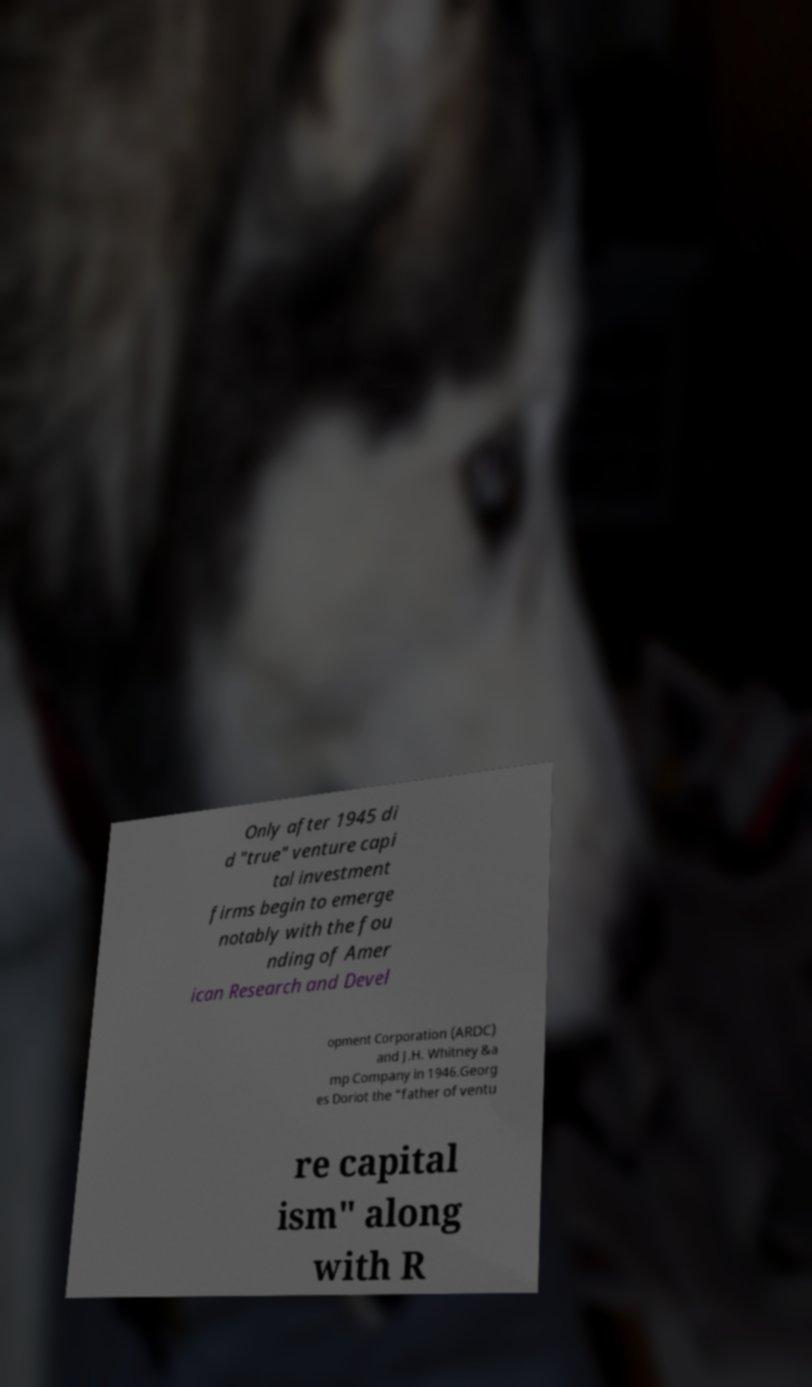Can you read and provide the text displayed in the image?This photo seems to have some interesting text. Can you extract and type it out for me? Only after 1945 di d "true" venture capi tal investment firms begin to emerge notably with the fou nding of Amer ican Research and Devel opment Corporation (ARDC) and J.H. Whitney &a mp Company in 1946.Georg es Doriot the "father of ventu re capital ism" along with R 